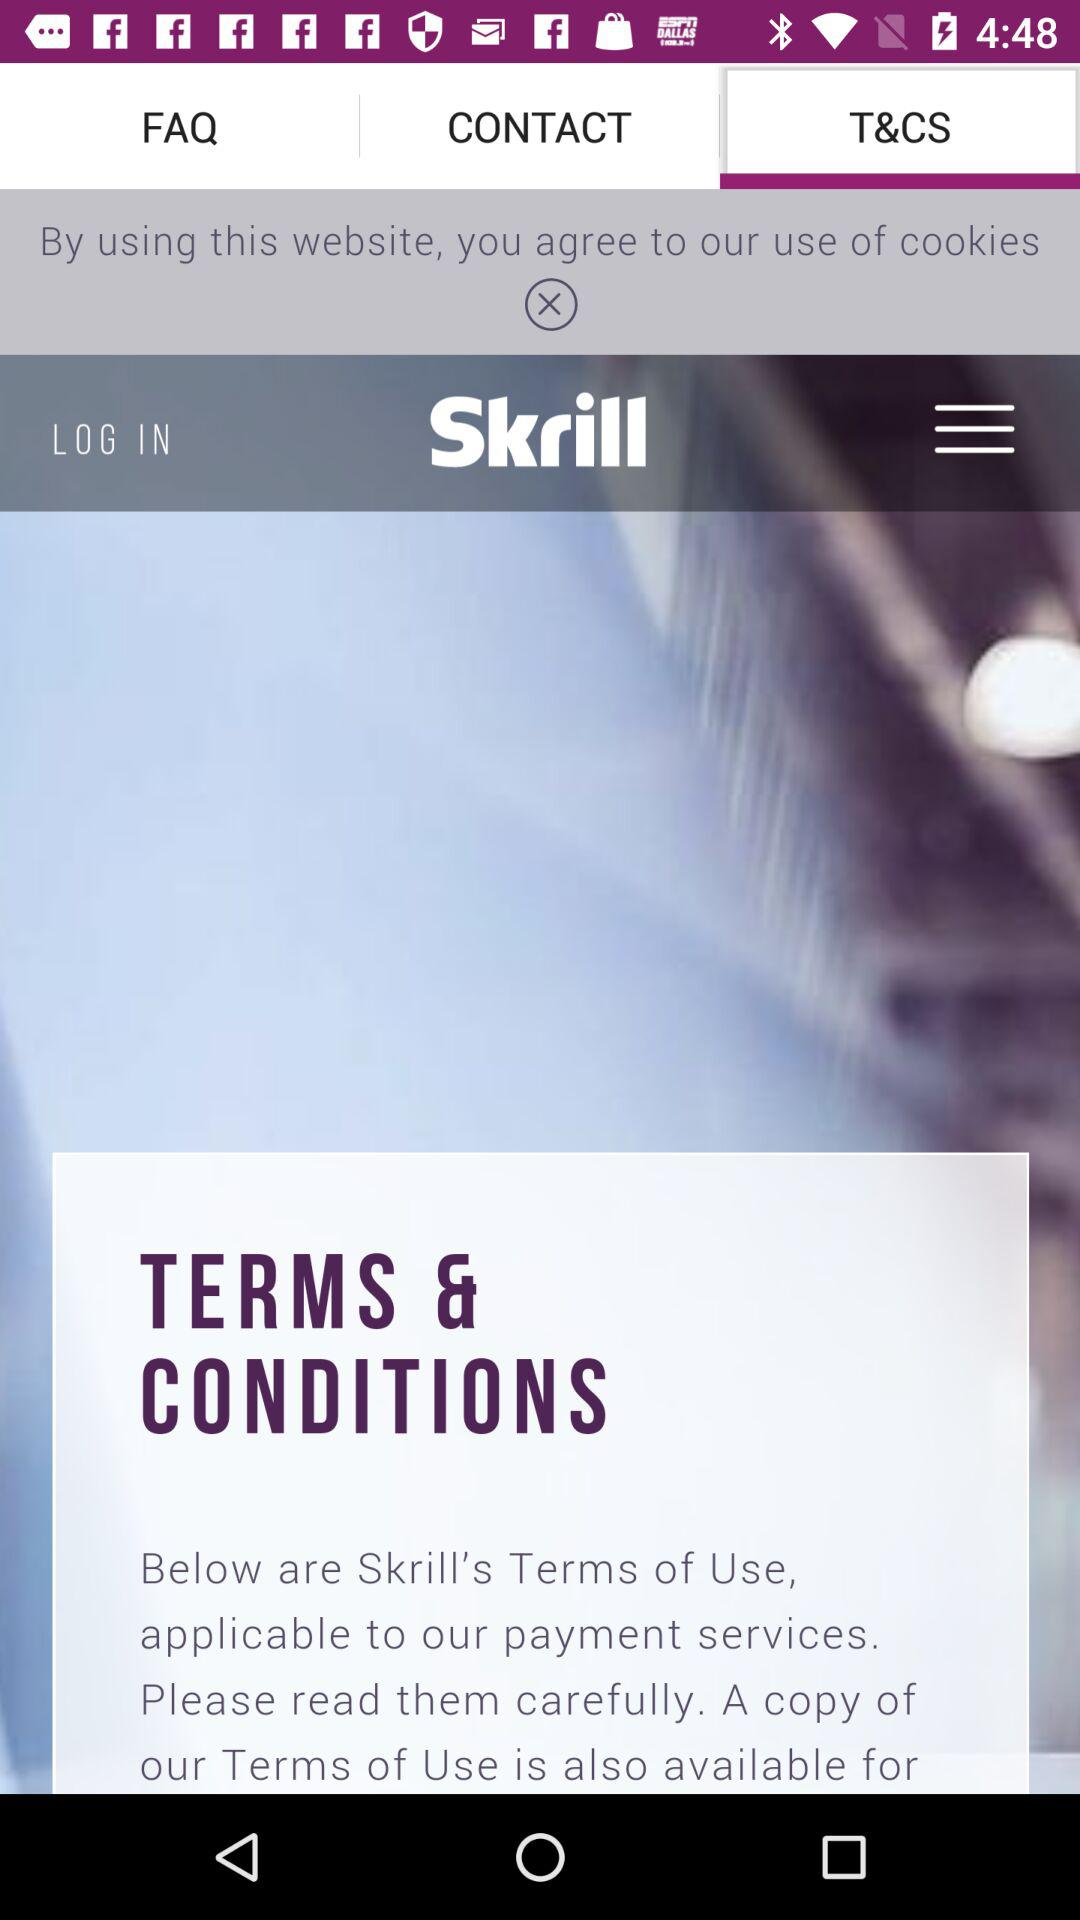What is the app name? The app name is "Skrill". 